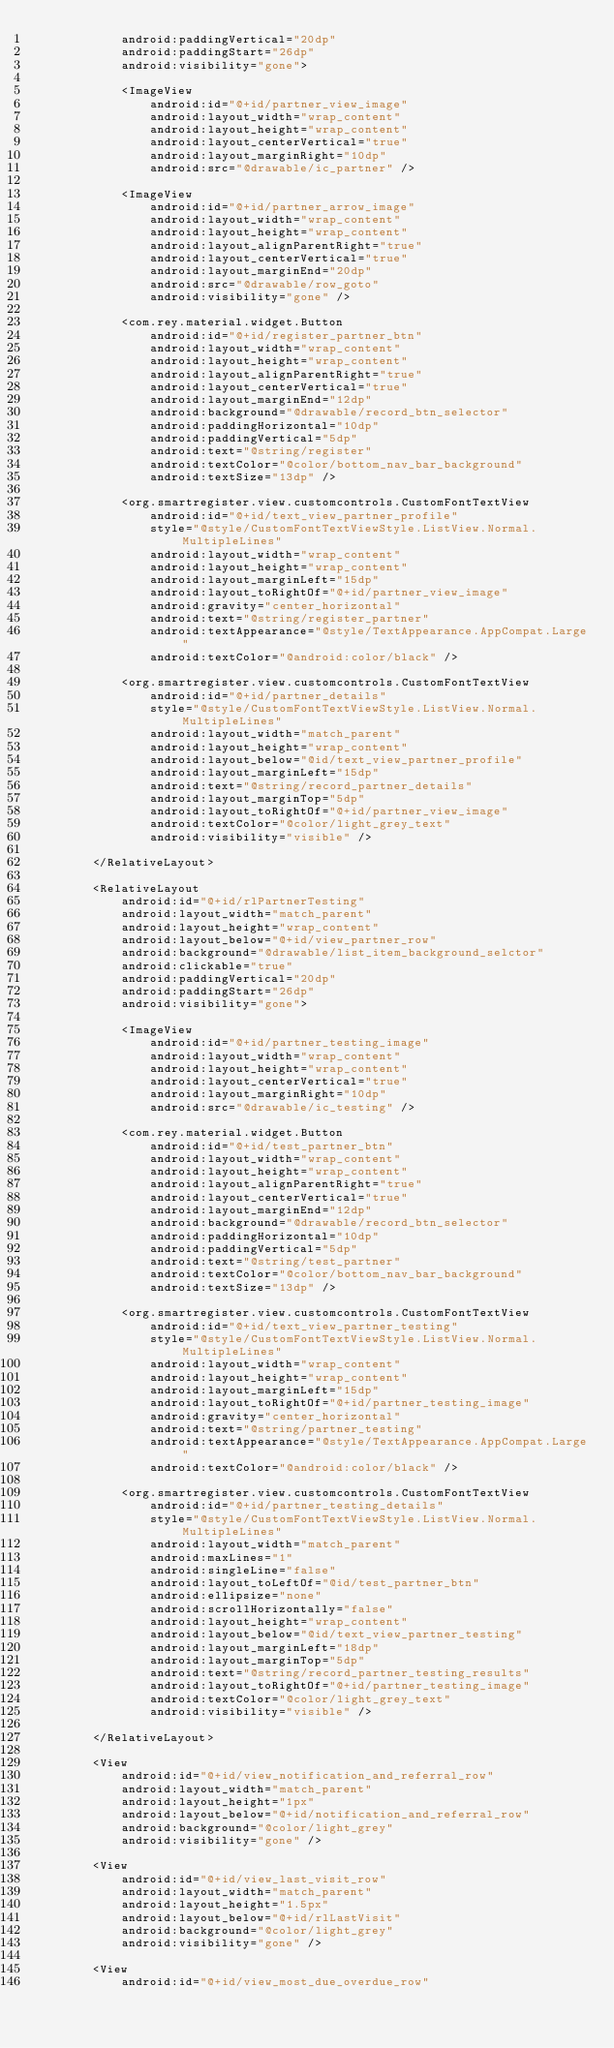<code> <loc_0><loc_0><loc_500><loc_500><_XML_>            android:paddingVertical="20dp"
            android:paddingStart="26dp"
            android:visibility="gone">

            <ImageView
                android:id="@+id/partner_view_image"
                android:layout_width="wrap_content"
                android:layout_height="wrap_content"
                android:layout_centerVertical="true"
                android:layout_marginRight="10dp"
                android:src="@drawable/ic_partner" />

            <ImageView
                android:id="@+id/partner_arrow_image"
                android:layout_width="wrap_content"
                android:layout_height="wrap_content"
                android:layout_alignParentRight="true"
                android:layout_centerVertical="true"
                android:layout_marginEnd="20dp"
                android:src="@drawable/row_goto"
                android:visibility="gone" />

            <com.rey.material.widget.Button
                android:id="@+id/register_partner_btn"
                android:layout_width="wrap_content"
                android:layout_height="wrap_content"
                android:layout_alignParentRight="true"
                android:layout_centerVertical="true"
                android:layout_marginEnd="12dp"
                android:background="@drawable/record_btn_selector"
                android:paddingHorizontal="10dp"
                android:paddingVertical="5dp"
                android:text="@string/register"
                android:textColor="@color/bottom_nav_bar_background"
                android:textSize="13dp" />

            <org.smartregister.view.customcontrols.CustomFontTextView
                android:id="@+id/text_view_partner_profile"
                style="@style/CustomFontTextViewStyle.ListView.Normal.MultipleLines"
                android:layout_width="wrap_content"
                android:layout_height="wrap_content"
                android:layout_marginLeft="15dp"
                android:layout_toRightOf="@+id/partner_view_image"
                android:gravity="center_horizontal"
                android:text="@string/register_partner"
                android:textAppearance="@style/TextAppearance.AppCompat.Large"
                android:textColor="@android:color/black" />

            <org.smartregister.view.customcontrols.CustomFontTextView
                android:id="@+id/partner_details"
                style="@style/CustomFontTextViewStyle.ListView.Normal.MultipleLines"
                android:layout_width="match_parent"
                android:layout_height="wrap_content"
                android:layout_below="@id/text_view_partner_profile"
                android:layout_marginLeft="15dp"
                android:text="@string/record_partner_details"
                android:layout_marginTop="5dp"
                android:layout_toRightOf="@+id/partner_view_image"
                android:textColor="@color/light_grey_text"
                android:visibility="visible" />

        </RelativeLayout>

        <RelativeLayout
            android:id="@+id/rlPartnerTesting"
            android:layout_width="match_parent"
            android:layout_height="wrap_content"
            android:layout_below="@+id/view_partner_row"
            android:background="@drawable/list_item_background_selctor"
            android:clickable="true"
            android:paddingVertical="20dp"
            android:paddingStart="26dp"
            android:visibility="gone">

            <ImageView
                android:id="@+id/partner_testing_image"
                android:layout_width="wrap_content"
                android:layout_height="wrap_content"
                android:layout_centerVertical="true"
                android:layout_marginRight="10dp"
                android:src="@drawable/ic_testing" />

            <com.rey.material.widget.Button
                android:id="@+id/test_partner_btn"
                android:layout_width="wrap_content"
                android:layout_height="wrap_content"
                android:layout_alignParentRight="true"
                android:layout_centerVertical="true"
                android:layout_marginEnd="12dp"
                android:background="@drawable/record_btn_selector"
                android:paddingHorizontal="10dp"
                android:paddingVertical="5dp"
                android:text="@string/test_partner"
                android:textColor="@color/bottom_nav_bar_background"
                android:textSize="13dp" />

            <org.smartregister.view.customcontrols.CustomFontTextView
                android:id="@+id/text_view_partner_testing"
                style="@style/CustomFontTextViewStyle.ListView.Normal.MultipleLines"
                android:layout_width="wrap_content"
                android:layout_height="wrap_content"
                android:layout_marginLeft="15dp"
                android:layout_toRightOf="@+id/partner_testing_image"
                android:gravity="center_horizontal"
                android:text="@string/partner_testing"
                android:textAppearance="@style/TextAppearance.AppCompat.Large"
                android:textColor="@android:color/black" />

            <org.smartregister.view.customcontrols.CustomFontTextView
                android:id="@+id/partner_testing_details"
                style="@style/CustomFontTextViewStyle.ListView.Normal.MultipleLines"
                android:layout_width="match_parent"
                android:maxLines="1"
                android:singleLine="false"
                android:layout_toLeftOf="@id/test_partner_btn"
                android:ellipsize="none"
                android:scrollHorizontally="false"
                android:layout_height="wrap_content"
                android:layout_below="@id/text_view_partner_testing"
                android:layout_marginLeft="18dp"
                android:layout_marginTop="5dp"
                android:text="@string/record_partner_testing_results"
                android:layout_toRightOf="@+id/partner_testing_image"
                android:textColor="@color/light_grey_text"
                android:visibility="visible" />

        </RelativeLayout>

        <View
            android:id="@+id/view_notification_and_referral_row"
            android:layout_width="match_parent"
            android:layout_height="1px"
            android:layout_below="@+id/notification_and_referral_row"
            android:background="@color/light_grey"
            android:visibility="gone" />

        <View
            android:id="@+id/view_last_visit_row"
            android:layout_width="match_parent"
            android:layout_height="1.5px"
            android:layout_below="@+id/rlLastVisit"
            android:background="@color/light_grey"
            android:visibility="gone" />

        <View
            android:id="@+id/view_most_due_overdue_row"</code> 